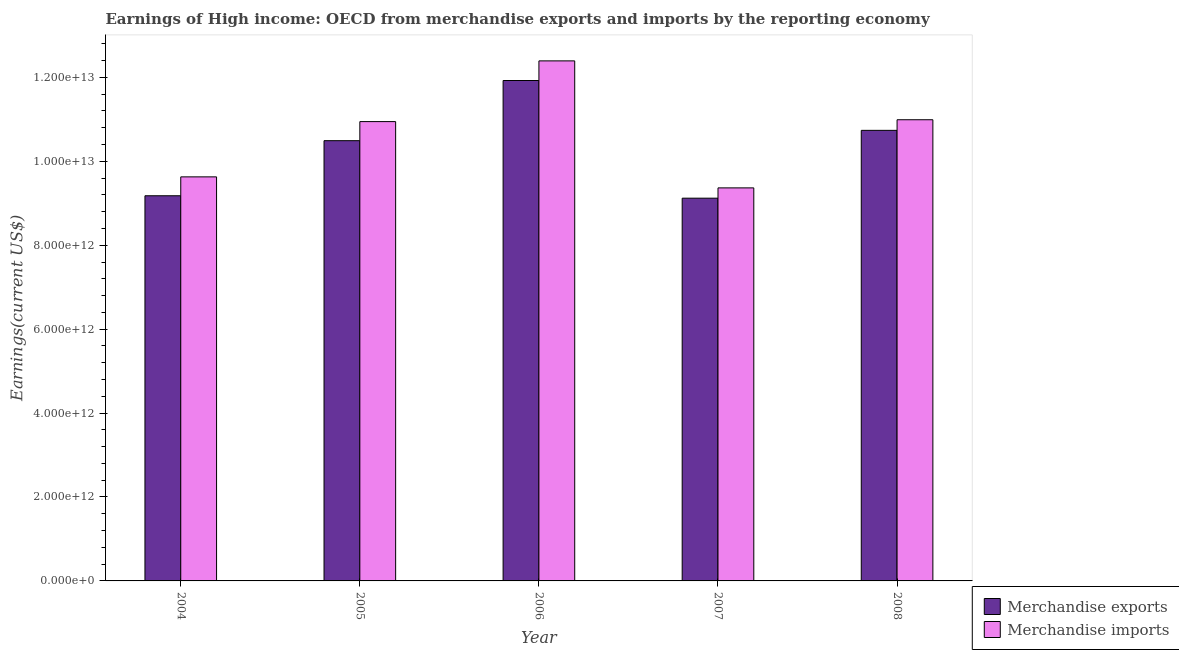Are the number of bars on each tick of the X-axis equal?
Your response must be concise. Yes. How many bars are there on the 2nd tick from the left?
Make the answer very short. 2. What is the earnings from merchandise exports in 2004?
Offer a very short reply. 9.18e+12. Across all years, what is the maximum earnings from merchandise imports?
Provide a short and direct response. 1.24e+13. Across all years, what is the minimum earnings from merchandise exports?
Offer a terse response. 9.12e+12. In which year was the earnings from merchandise imports maximum?
Provide a succinct answer. 2006. What is the total earnings from merchandise exports in the graph?
Your answer should be compact. 5.15e+13. What is the difference between the earnings from merchandise exports in 2005 and that in 2006?
Provide a succinct answer. -1.43e+12. What is the difference between the earnings from merchandise exports in 2005 and the earnings from merchandise imports in 2004?
Your response must be concise. 1.31e+12. What is the average earnings from merchandise exports per year?
Your answer should be very brief. 1.03e+13. In the year 2008, what is the difference between the earnings from merchandise imports and earnings from merchandise exports?
Give a very brief answer. 0. In how many years, is the earnings from merchandise imports greater than 10400000000000 US$?
Keep it short and to the point. 3. What is the ratio of the earnings from merchandise imports in 2005 to that in 2008?
Your response must be concise. 1. What is the difference between the highest and the second highest earnings from merchandise exports?
Make the answer very short. 1.19e+12. What is the difference between the highest and the lowest earnings from merchandise exports?
Your answer should be compact. 2.80e+12. In how many years, is the earnings from merchandise exports greater than the average earnings from merchandise exports taken over all years?
Your answer should be compact. 3. What does the 2nd bar from the right in 2007 represents?
Offer a terse response. Merchandise exports. How many bars are there?
Offer a terse response. 10. Are all the bars in the graph horizontal?
Your answer should be very brief. No. How many years are there in the graph?
Make the answer very short. 5. What is the difference between two consecutive major ticks on the Y-axis?
Your answer should be very brief. 2.00e+12. Does the graph contain any zero values?
Your answer should be compact. No. Where does the legend appear in the graph?
Provide a short and direct response. Bottom right. How are the legend labels stacked?
Give a very brief answer. Vertical. What is the title of the graph?
Offer a very short reply. Earnings of High income: OECD from merchandise exports and imports by the reporting economy. What is the label or title of the Y-axis?
Ensure brevity in your answer.  Earnings(current US$). What is the Earnings(current US$) in Merchandise exports in 2004?
Keep it short and to the point. 9.18e+12. What is the Earnings(current US$) of Merchandise imports in 2004?
Keep it short and to the point. 9.63e+12. What is the Earnings(current US$) in Merchandise exports in 2005?
Ensure brevity in your answer.  1.05e+13. What is the Earnings(current US$) of Merchandise imports in 2005?
Offer a terse response. 1.09e+13. What is the Earnings(current US$) of Merchandise exports in 2006?
Offer a very short reply. 1.19e+13. What is the Earnings(current US$) in Merchandise imports in 2006?
Ensure brevity in your answer.  1.24e+13. What is the Earnings(current US$) of Merchandise exports in 2007?
Provide a short and direct response. 9.12e+12. What is the Earnings(current US$) of Merchandise imports in 2007?
Your answer should be very brief. 9.37e+12. What is the Earnings(current US$) of Merchandise exports in 2008?
Provide a succinct answer. 1.07e+13. What is the Earnings(current US$) of Merchandise imports in 2008?
Give a very brief answer. 1.10e+13. Across all years, what is the maximum Earnings(current US$) of Merchandise exports?
Your response must be concise. 1.19e+13. Across all years, what is the maximum Earnings(current US$) of Merchandise imports?
Offer a very short reply. 1.24e+13. Across all years, what is the minimum Earnings(current US$) of Merchandise exports?
Provide a short and direct response. 9.12e+12. Across all years, what is the minimum Earnings(current US$) in Merchandise imports?
Make the answer very short. 9.37e+12. What is the total Earnings(current US$) of Merchandise exports in the graph?
Your answer should be very brief. 5.15e+13. What is the total Earnings(current US$) in Merchandise imports in the graph?
Make the answer very short. 5.33e+13. What is the difference between the Earnings(current US$) of Merchandise exports in 2004 and that in 2005?
Keep it short and to the point. -1.31e+12. What is the difference between the Earnings(current US$) in Merchandise imports in 2004 and that in 2005?
Provide a short and direct response. -1.32e+12. What is the difference between the Earnings(current US$) of Merchandise exports in 2004 and that in 2006?
Provide a short and direct response. -2.75e+12. What is the difference between the Earnings(current US$) in Merchandise imports in 2004 and that in 2006?
Offer a very short reply. -2.76e+12. What is the difference between the Earnings(current US$) in Merchandise exports in 2004 and that in 2007?
Offer a terse response. 5.77e+1. What is the difference between the Earnings(current US$) of Merchandise imports in 2004 and that in 2007?
Provide a short and direct response. 2.63e+11. What is the difference between the Earnings(current US$) of Merchandise exports in 2004 and that in 2008?
Provide a succinct answer. -1.56e+12. What is the difference between the Earnings(current US$) in Merchandise imports in 2004 and that in 2008?
Give a very brief answer. -1.36e+12. What is the difference between the Earnings(current US$) in Merchandise exports in 2005 and that in 2006?
Keep it short and to the point. -1.43e+12. What is the difference between the Earnings(current US$) in Merchandise imports in 2005 and that in 2006?
Provide a short and direct response. -1.45e+12. What is the difference between the Earnings(current US$) of Merchandise exports in 2005 and that in 2007?
Provide a succinct answer. 1.37e+12. What is the difference between the Earnings(current US$) in Merchandise imports in 2005 and that in 2007?
Ensure brevity in your answer.  1.58e+12. What is the difference between the Earnings(current US$) of Merchandise exports in 2005 and that in 2008?
Offer a very short reply. -2.46e+11. What is the difference between the Earnings(current US$) of Merchandise imports in 2005 and that in 2008?
Your response must be concise. -4.43e+1. What is the difference between the Earnings(current US$) in Merchandise exports in 2006 and that in 2007?
Make the answer very short. 2.80e+12. What is the difference between the Earnings(current US$) in Merchandise imports in 2006 and that in 2007?
Your response must be concise. 3.03e+12. What is the difference between the Earnings(current US$) of Merchandise exports in 2006 and that in 2008?
Offer a terse response. 1.19e+12. What is the difference between the Earnings(current US$) in Merchandise imports in 2006 and that in 2008?
Offer a very short reply. 1.40e+12. What is the difference between the Earnings(current US$) in Merchandise exports in 2007 and that in 2008?
Make the answer very short. -1.62e+12. What is the difference between the Earnings(current US$) of Merchandise imports in 2007 and that in 2008?
Your response must be concise. -1.62e+12. What is the difference between the Earnings(current US$) in Merchandise exports in 2004 and the Earnings(current US$) in Merchandise imports in 2005?
Offer a very short reply. -1.77e+12. What is the difference between the Earnings(current US$) of Merchandise exports in 2004 and the Earnings(current US$) of Merchandise imports in 2006?
Give a very brief answer. -3.21e+12. What is the difference between the Earnings(current US$) in Merchandise exports in 2004 and the Earnings(current US$) in Merchandise imports in 2007?
Your answer should be very brief. -1.88e+11. What is the difference between the Earnings(current US$) of Merchandise exports in 2004 and the Earnings(current US$) of Merchandise imports in 2008?
Your response must be concise. -1.81e+12. What is the difference between the Earnings(current US$) in Merchandise exports in 2005 and the Earnings(current US$) in Merchandise imports in 2006?
Offer a terse response. -1.90e+12. What is the difference between the Earnings(current US$) in Merchandise exports in 2005 and the Earnings(current US$) in Merchandise imports in 2007?
Ensure brevity in your answer.  1.12e+12. What is the difference between the Earnings(current US$) in Merchandise exports in 2005 and the Earnings(current US$) in Merchandise imports in 2008?
Ensure brevity in your answer.  -4.99e+11. What is the difference between the Earnings(current US$) of Merchandise exports in 2006 and the Earnings(current US$) of Merchandise imports in 2007?
Provide a short and direct response. 2.56e+12. What is the difference between the Earnings(current US$) of Merchandise exports in 2006 and the Earnings(current US$) of Merchandise imports in 2008?
Your answer should be compact. 9.35e+11. What is the difference between the Earnings(current US$) of Merchandise exports in 2007 and the Earnings(current US$) of Merchandise imports in 2008?
Ensure brevity in your answer.  -1.87e+12. What is the average Earnings(current US$) in Merchandise exports per year?
Offer a very short reply. 1.03e+13. What is the average Earnings(current US$) of Merchandise imports per year?
Give a very brief answer. 1.07e+13. In the year 2004, what is the difference between the Earnings(current US$) in Merchandise exports and Earnings(current US$) in Merchandise imports?
Your answer should be very brief. -4.50e+11. In the year 2005, what is the difference between the Earnings(current US$) of Merchandise exports and Earnings(current US$) of Merchandise imports?
Keep it short and to the point. -4.55e+11. In the year 2006, what is the difference between the Earnings(current US$) in Merchandise exports and Earnings(current US$) in Merchandise imports?
Your response must be concise. -4.68e+11. In the year 2007, what is the difference between the Earnings(current US$) in Merchandise exports and Earnings(current US$) in Merchandise imports?
Make the answer very short. -2.45e+11. In the year 2008, what is the difference between the Earnings(current US$) of Merchandise exports and Earnings(current US$) of Merchandise imports?
Your answer should be very brief. -2.53e+11. What is the ratio of the Earnings(current US$) in Merchandise exports in 2004 to that in 2005?
Offer a terse response. 0.87. What is the ratio of the Earnings(current US$) of Merchandise imports in 2004 to that in 2005?
Keep it short and to the point. 0.88. What is the ratio of the Earnings(current US$) of Merchandise exports in 2004 to that in 2006?
Keep it short and to the point. 0.77. What is the ratio of the Earnings(current US$) of Merchandise imports in 2004 to that in 2006?
Your response must be concise. 0.78. What is the ratio of the Earnings(current US$) in Merchandise exports in 2004 to that in 2007?
Your answer should be compact. 1.01. What is the ratio of the Earnings(current US$) in Merchandise imports in 2004 to that in 2007?
Keep it short and to the point. 1.03. What is the ratio of the Earnings(current US$) of Merchandise exports in 2004 to that in 2008?
Your answer should be compact. 0.85. What is the ratio of the Earnings(current US$) in Merchandise imports in 2004 to that in 2008?
Ensure brevity in your answer.  0.88. What is the ratio of the Earnings(current US$) of Merchandise exports in 2005 to that in 2006?
Give a very brief answer. 0.88. What is the ratio of the Earnings(current US$) of Merchandise imports in 2005 to that in 2006?
Give a very brief answer. 0.88. What is the ratio of the Earnings(current US$) in Merchandise exports in 2005 to that in 2007?
Give a very brief answer. 1.15. What is the ratio of the Earnings(current US$) of Merchandise imports in 2005 to that in 2007?
Offer a terse response. 1.17. What is the ratio of the Earnings(current US$) of Merchandise exports in 2005 to that in 2008?
Give a very brief answer. 0.98. What is the ratio of the Earnings(current US$) of Merchandise exports in 2006 to that in 2007?
Make the answer very short. 1.31. What is the ratio of the Earnings(current US$) of Merchandise imports in 2006 to that in 2007?
Provide a short and direct response. 1.32. What is the ratio of the Earnings(current US$) of Merchandise exports in 2006 to that in 2008?
Ensure brevity in your answer.  1.11. What is the ratio of the Earnings(current US$) in Merchandise imports in 2006 to that in 2008?
Your answer should be very brief. 1.13. What is the ratio of the Earnings(current US$) in Merchandise exports in 2007 to that in 2008?
Your answer should be compact. 0.85. What is the ratio of the Earnings(current US$) in Merchandise imports in 2007 to that in 2008?
Your answer should be very brief. 0.85. What is the difference between the highest and the second highest Earnings(current US$) in Merchandise exports?
Ensure brevity in your answer.  1.19e+12. What is the difference between the highest and the second highest Earnings(current US$) in Merchandise imports?
Ensure brevity in your answer.  1.40e+12. What is the difference between the highest and the lowest Earnings(current US$) of Merchandise exports?
Make the answer very short. 2.80e+12. What is the difference between the highest and the lowest Earnings(current US$) of Merchandise imports?
Provide a succinct answer. 3.03e+12. 